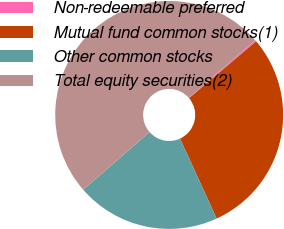<chart> <loc_0><loc_0><loc_500><loc_500><pie_chart><fcel>Non-redeemable preferred<fcel>Mutual fund common stocks(1)<fcel>Other common stocks<fcel>Total equity securities(2)<nl><fcel>0.21%<fcel>29.34%<fcel>20.44%<fcel>50.0%<nl></chart> 